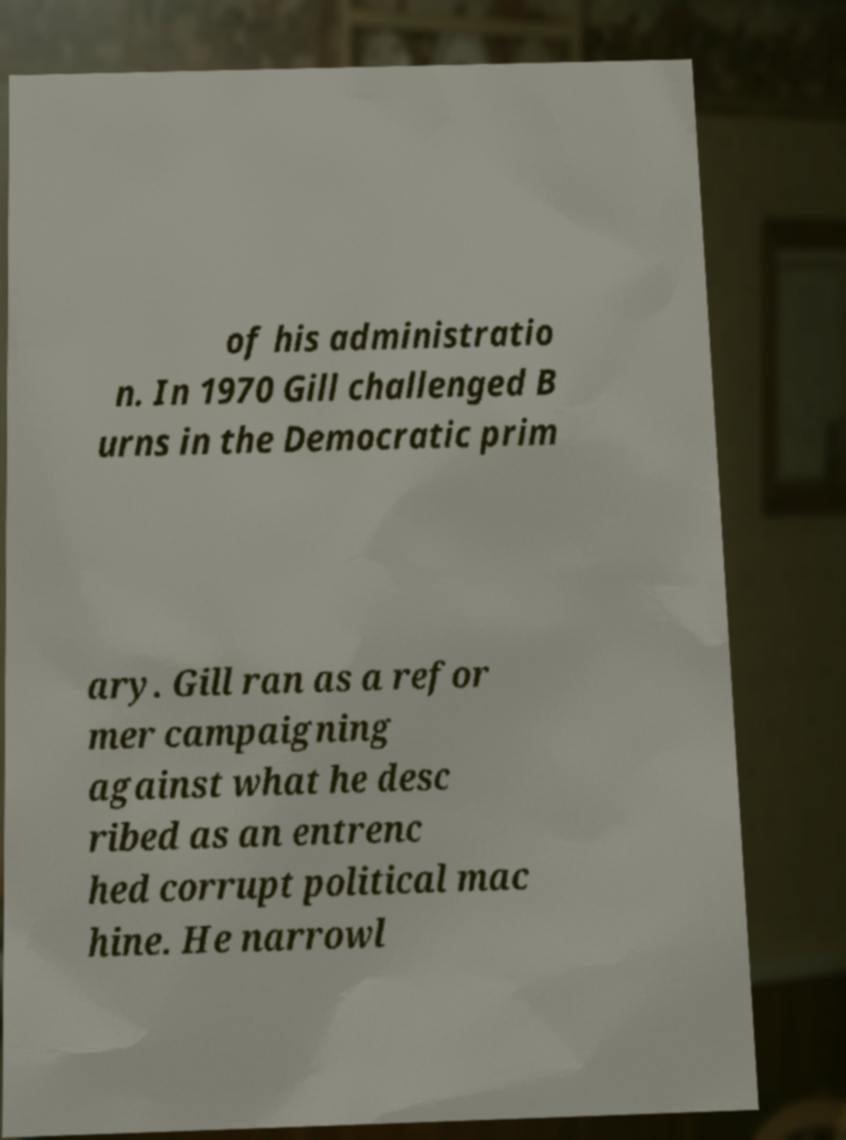What messages or text are displayed in this image? I need them in a readable, typed format. of his administratio n. In 1970 Gill challenged B urns in the Democratic prim ary. Gill ran as a refor mer campaigning against what he desc ribed as an entrenc hed corrupt political mac hine. He narrowl 